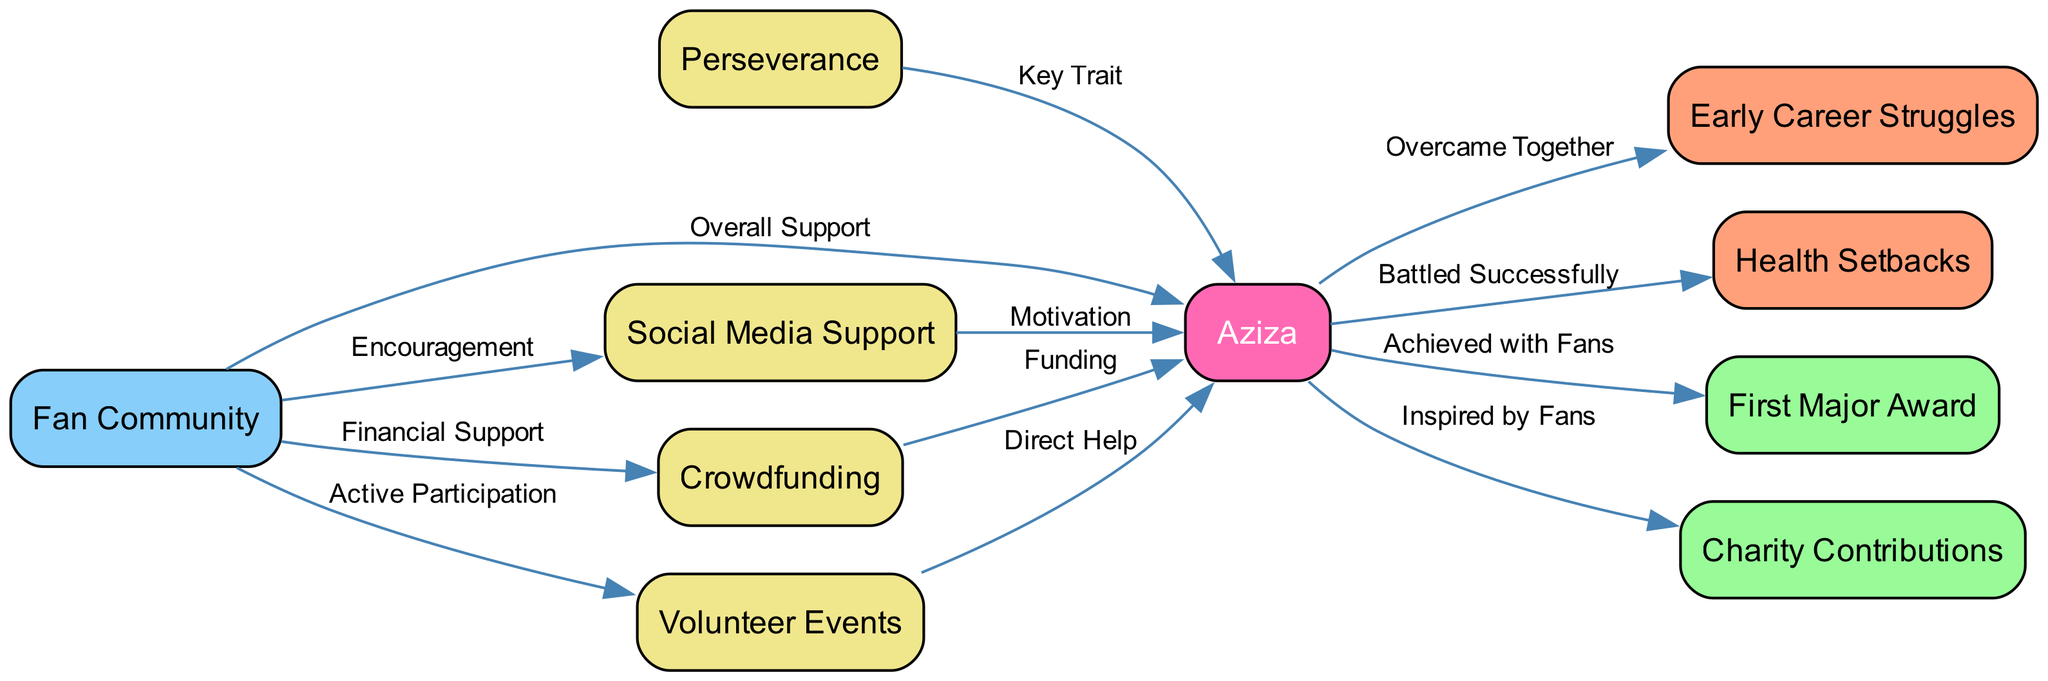What is the total number of nodes in the diagram? To find the total number of nodes, we count each unique entry in the "nodes" array. There are 10 nodes listed: Aziza, Perseverance, Early Career Struggles, Health Setbacks, First Major Award, Charity Contributions, Fan Community, Social Media Support, Crowdfunding, and Volunteer Events.
Answer: 10 What type of relationship exists between the Fan Community and Aziza? The edge from the Fan Community to Aziza is labeled "Overall Support," indicating a supportive relationship. This connection shows that the Fan Community plays an important role in backing Aziza.
Answer: Overall Support How many edges are there in the diagram? We determine the total number of edges by counting each relationship connection in the "edges" array. There are 12 edges present in total.
Answer: 12 Which challenge did Aziza overcome with her fans? The edge from Aziza to Early Career Struggles is labeled "Overcame Together," indicating that this challenge was a collective effort between Aziza and her fans.
Answer: Early Career Struggles What is the primary motivation provided to Aziza by the Fan Community? The edge labeled "Motivation" connects Social Media Support to Aziza, indicating that this is the primary way fans provide motivation. The connection emphasizes the significance of social media in boosting Aziza's morale.
Answer: Motivation How does the Fan Community specifically assist Aziza financially? The edge from the Fan Community to Crowdfunding is labeled "Financial Support," indicating that financial backing for Aziza comes from crowdfunding efforts organized by her fans.
Answer: Financial Support Which milestone is associated with Aziza's achievements alongside her fans? The edge from Aziza to First Major Award is labeled "Achieved with Fans," indicating that this milestone was reached as a collaborative accomplishment between Aziza and her fan base.
Answer: First Major Award What does Perseverance represent in relation to Aziza? The edge from Perseverance to Aziza is labeled "Key Trait," which suggests that Perseverance is a significant characteristic attributed to Aziza, highlighting her resilience and determination.
Answer: Key Trait Which form of support involves active participation from fans? The edge from Fan Community to Volunteer Events is labeled "Active Participation," signifying that fans engage in hands-on activities to show their support for Aziza.
Answer: Active Participation 